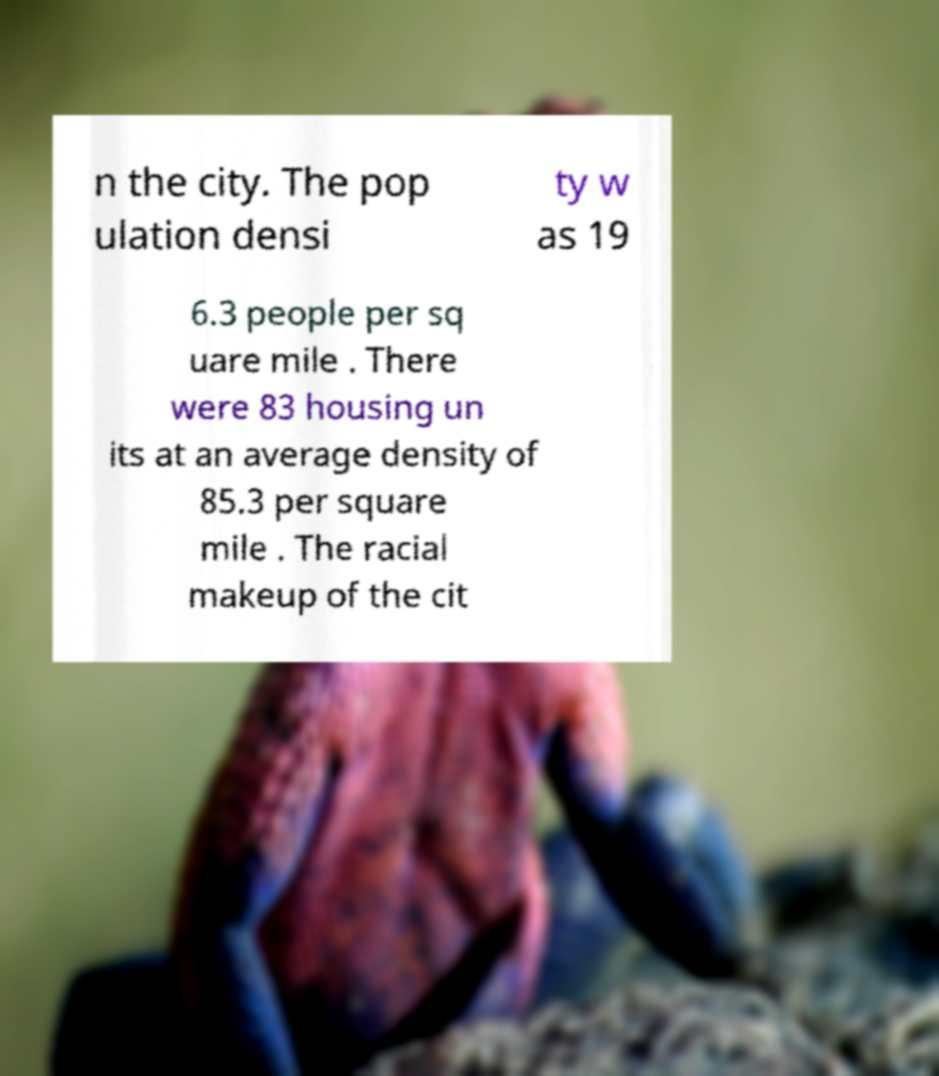Please identify and transcribe the text found in this image. n the city. The pop ulation densi ty w as 19 6.3 people per sq uare mile . There were 83 housing un its at an average density of 85.3 per square mile . The racial makeup of the cit 